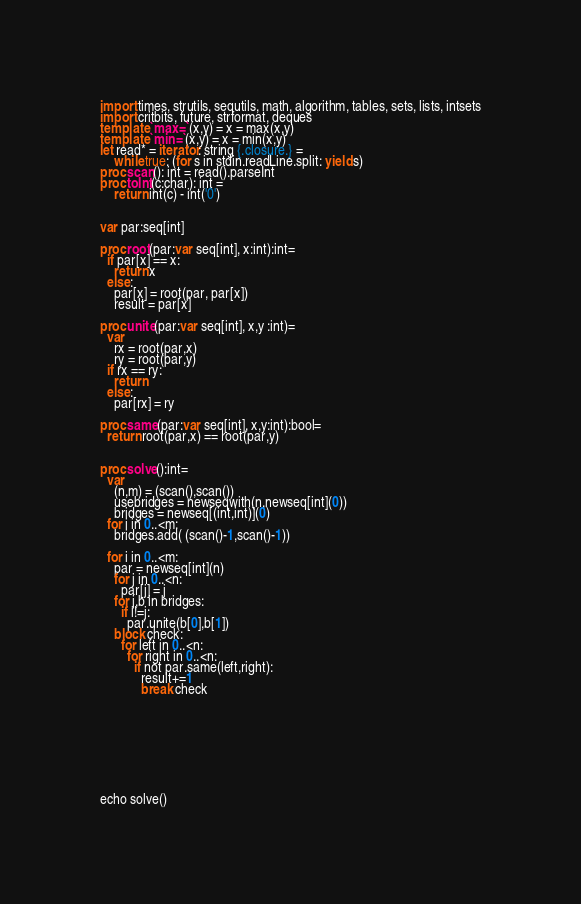<code> <loc_0><loc_0><loc_500><loc_500><_Nim_>import times, strutils, sequtils, math, algorithm, tables, sets, lists, intsets
import critbits, future, strformat, deques
template `max=`(x,y) = x = max(x,y)
template `min=`(x,y) = x = min(x,y)
let read* = iterator: string {.closure.} =
    while true: (for s in stdin.readLine.split: yield s)
proc scan(): int = read().parseInt
proc toInt(c:char): int =
    return int(c) - int('0')


var par:seq[int]  

proc root(par:var seq[int], x:int):int=
  if par[x] == x:
    return x
  else:
    par[x] = root(par, par[x])
    result = par[x]

proc unite(par:var seq[int], x,y :int)=
  var
    rx = root(par,x)
    ry = root(par,y)
  if rx == ry:
    return
  else:
    par[rx] = ry

proc same(par:var seq[int], x,y:int):bool=
  return root(par,x) == root(par,y)


proc solve():int=
  var
    (n,m) = (scan(),scan())
    usebridges = newseqwith(n,newseq[int](0))
    bridges = newseq[(int,int)](0)
  for i in 0..<m:
    bridges.add( (scan()-1,scan()-1))

  for i in 0..<m:
    par = newseq[int](n)
    for j in 0..<n:
      par[j] = j
    for j,b in bridges:
      if i!=j:
        par.unite(b[0],b[1])
    block check:
      for left in 0..<n:
        for right in 0..<n:
          if not par.same(left,right):
            result+=1
            break check
          


  
  
    

    
  
echo solve()</code> 